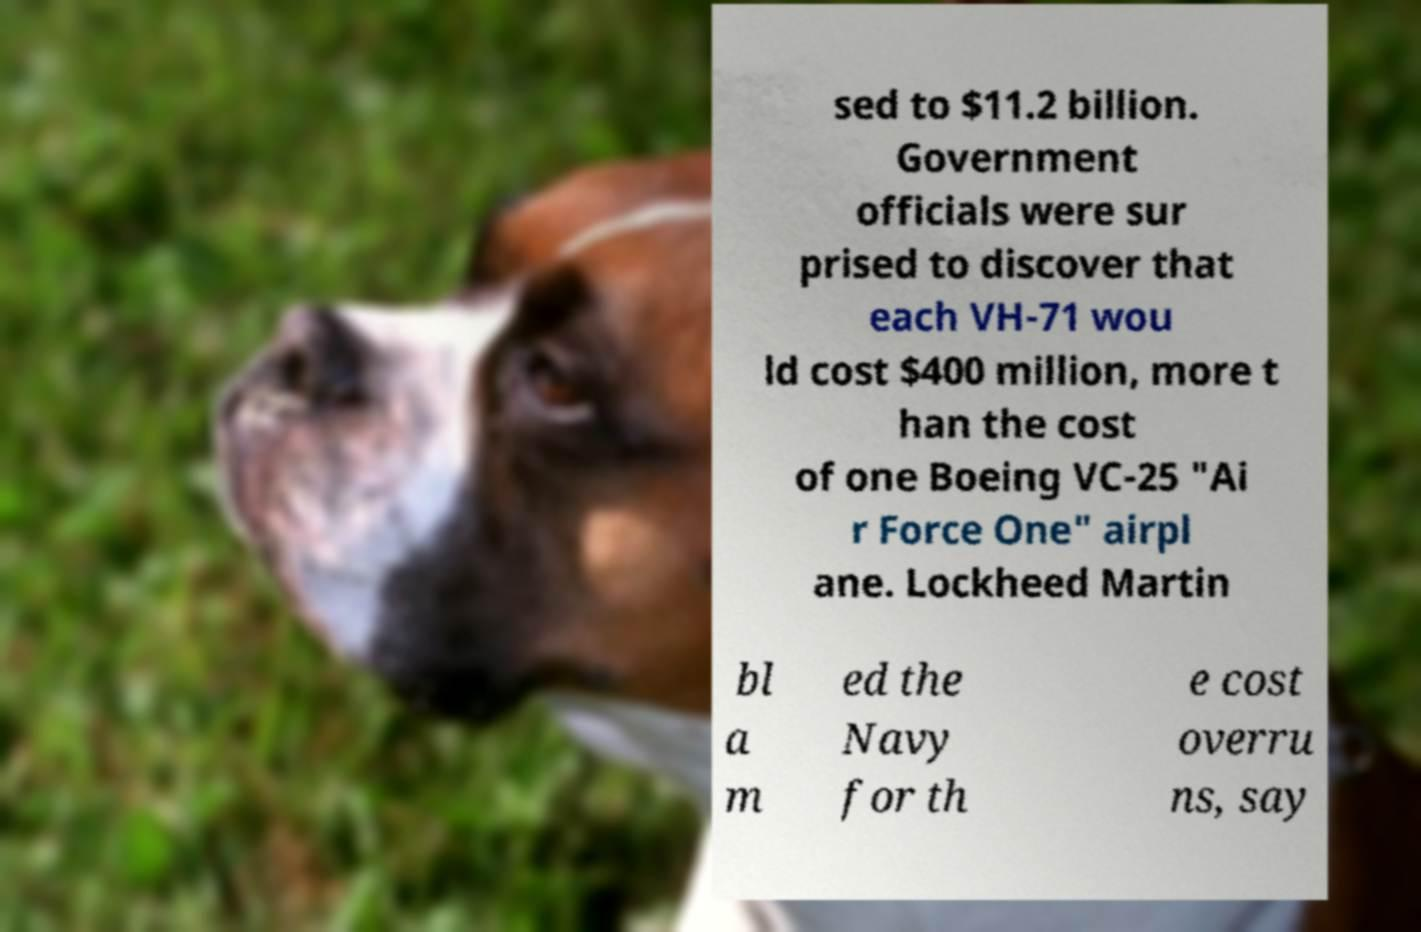Could you assist in decoding the text presented in this image and type it out clearly? sed to $11.2 billion. Government officials were sur prised to discover that each VH-71 wou ld cost $400 million, more t han the cost of one Boeing VC-25 "Ai r Force One" airpl ane. Lockheed Martin bl a m ed the Navy for th e cost overru ns, say 